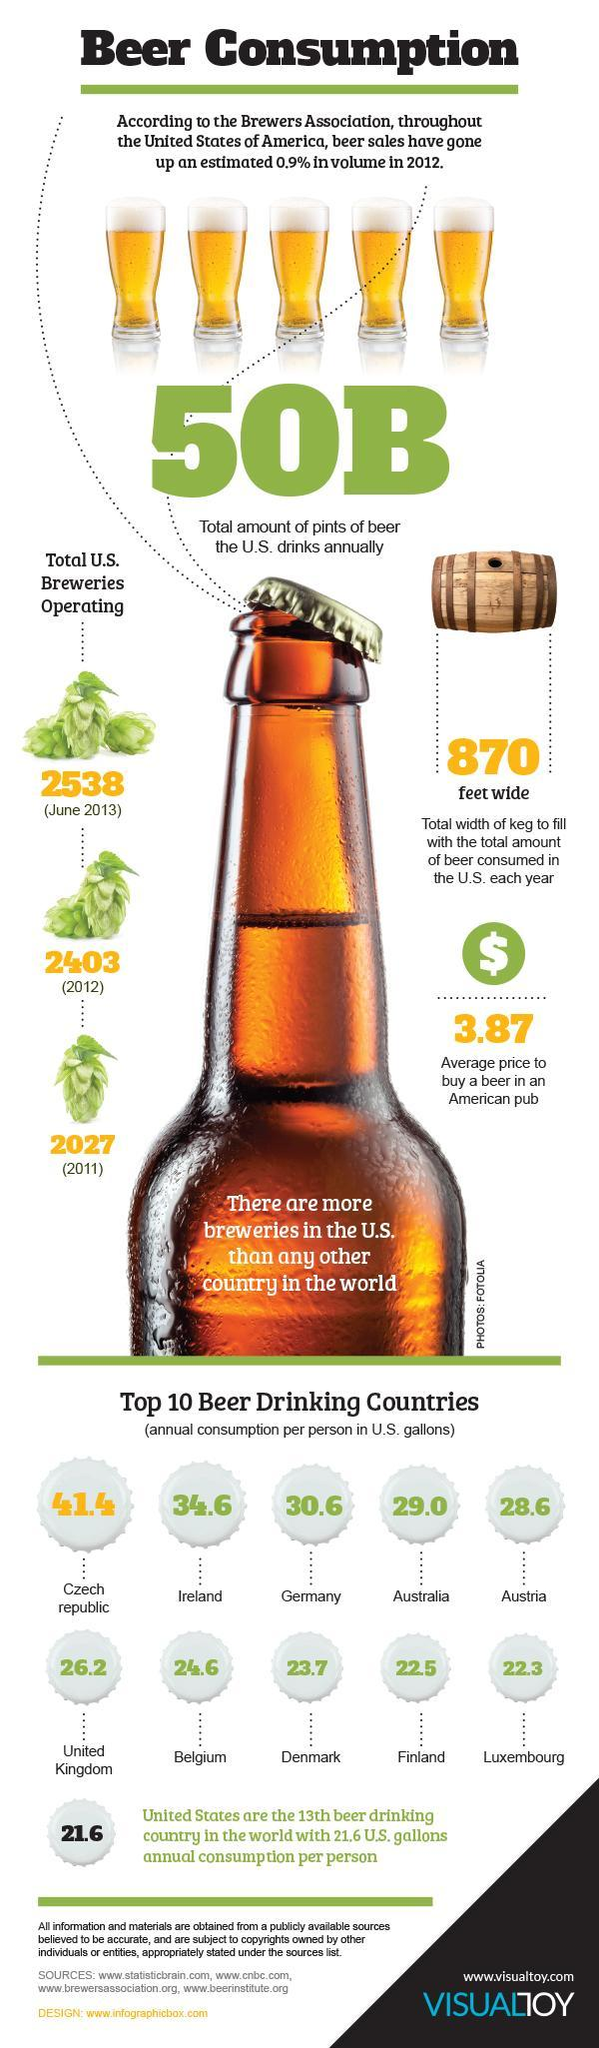what is the average annual consumption of Germany and Australia
Answer the question with a short phrase. 29.8 what has been the increase in breweries from 2012 to 2013 135 which country is the second lowest in beer consumption Finland how many glasses of beer are shown 5 which drink is being discussed beer what is the difference between the average annual consumption of Finland and US 0.9 